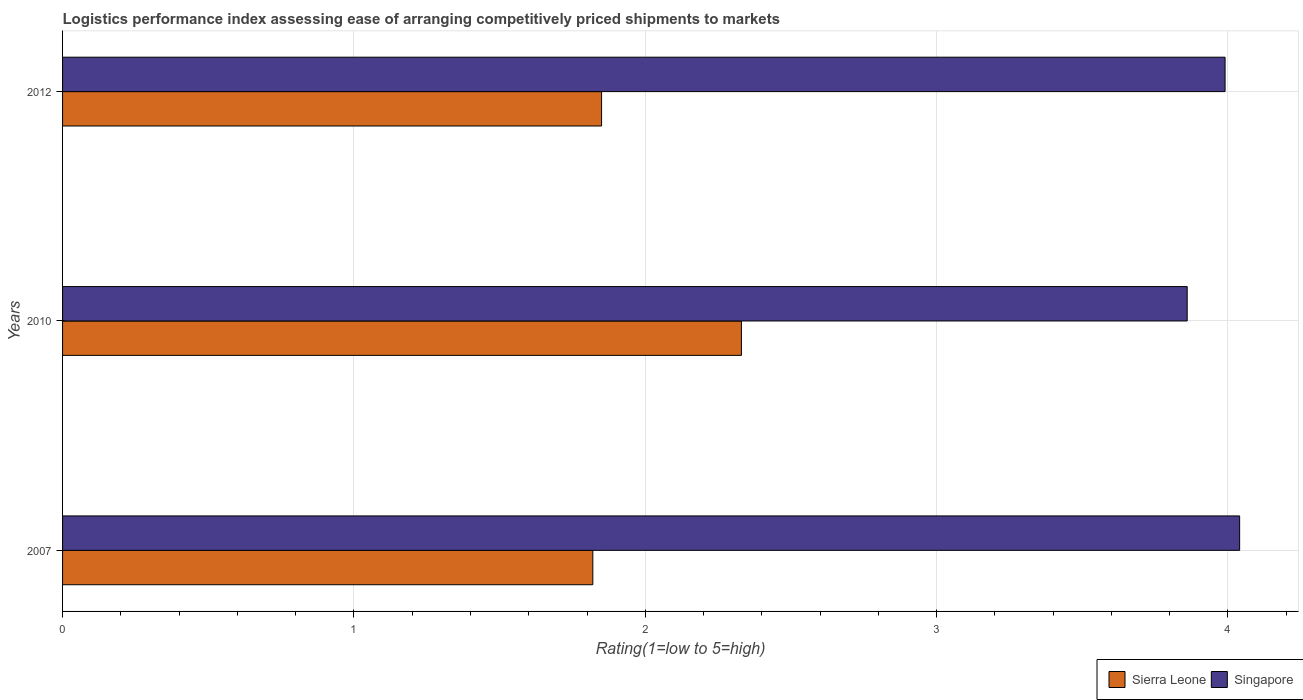How many different coloured bars are there?
Make the answer very short. 2. How many groups of bars are there?
Make the answer very short. 3. Are the number of bars per tick equal to the number of legend labels?
Offer a very short reply. Yes. In how many cases, is the number of bars for a given year not equal to the number of legend labels?
Keep it short and to the point. 0. What is the Logistic performance index in Sierra Leone in 2010?
Your answer should be compact. 2.33. Across all years, what is the maximum Logistic performance index in Singapore?
Keep it short and to the point. 4.04. Across all years, what is the minimum Logistic performance index in Sierra Leone?
Keep it short and to the point. 1.82. In which year was the Logistic performance index in Sierra Leone minimum?
Provide a succinct answer. 2007. What is the difference between the Logistic performance index in Singapore in 2007 and that in 2010?
Offer a very short reply. 0.18. What is the difference between the Logistic performance index in Singapore in 2010 and the Logistic performance index in Sierra Leone in 2007?
Provide a succinct answer. 2.04. What is the average Logistic performance index in Singapore per year?
Make the answer very short. 3.96. In the year 2010, what is the difference between the Logistic performance index in Singapore and Logistic performance index in Sierra Leone?
Your answer should be very brief. 1.53. In how many years, is the Logistic performance index in Sierra Leone greater than 3.4 ?
Offer a very short reply. 0. What is the ratio of the Logistic performance index in Sierra Leone in 2007 to that in 2012?
Provide a short and direct response. 0.98. Is the Logistic performance index in Sierra Leone in 2007 less than that in 2010?
Offer a terse response. Yes. Is the difference between the Logistic performance index in Singapore in 2010 and 2012 greater than the difference between the Logistic performance index in Sierra Leone in 2010 and 2012?
Your answer should be very brief. No. What is the difference between the highest and the second highest Logistic performance index in Sierra Leone?
Ensure brevity in your answer.  0.48. What is the difference between the highest and the lowest Logistic performance index in Singapore?
Ensure brevity in your answer.  0.18. In how many years, is the Logistic performance index in Singapore greater than the average Logistic performance index in Singapore taken over all years?
Offer a terse response. 2. Is the sum of the Logistic performance index in Singapore in 2007 and 2010 greater than the maximum Logistic performance index in Sierra Leone across all years?
Provide a short and direct response. Yes. What does the 2nd bar from the top in 2007 represents?
Ensure brevity in your answer.  Sierra Leone. What does the 1st bar from the bottom in 2010 represents?
Give a very brief answer. Sierra Leone. How many bars are there?
Keep it short and to the point. 6. How many years are there in the graph?
Your response must be concise. 3. What is the difference between two consecutive major ticks on the X-axis?
Your answer should be compact. 1. Are the values on the major ticks of X-axis written in scientific E-notation?
Provide a succinct answer. No. Does the graph contain any zero values?
Offer a terse response. No. Does the graph contain grids?
Keep it short and to the point. Yes. What is the title of the graph?
Your response must be concise. Logistics performance index assessing ease of arranging competitively priced shipments to markets. What is the label or title of the X-axis?
Your answer should be very brief. Rating(1=low to 5=high). What is the label or title of the Y-axis?
Your answer should be very brief. Years. What is the Rating(1=low to 5=high) in Sierra Leone in 2007?
Ensure brevity in your answer.  1.82. What is the Rating(1=low to 5=high) in Singapore in 2007?
Make the answer very short. 4.04. What is the Rating(1=low to 5=high) in Sierra Leone in 2010?
Provide a short and direct response. 2.33. What is the Rating(1=low to 5=high) of Singapore in 2010?
Your answer should be very brief. 3.86. What is the Rating(1=low to 5=high) in Sierra Leone in 2012?
Make the answer very short. 1.85. What is the Rating(1=low to 5=high) of Singapore in 2012?
Ensure brevity in your answer.  3.99. Across all years, what is the maximum Rating(1=low to 5=high) of Sierra Leone?
Give a very brief answer. 2.33. Across all years, what is the maximum Rating(1=low to 5=high) of Singapore?
Your answer should be compact. 4.04. Across all years, what is the minimum Rating(1=low to 5=high) of Sierra Leone?
Offer a very short reply. 1.82. Across all years, what is the minimum Rating(1=low to 5=high) of Singapore?
Give a very brief answer. 3.86. What is the total Rating(1=low to 5=high) of Singapore in the graph?
Your answer should be compact. 11.89. What is the difference between the Rating(1=low to 5=high) in Sierra Leone in 2007 and that in 2010?
Your answer should be very brief. -0.51. What is the difference between the Rating(1=low to 5=high) of Singapore in 2007 and that in 2010?
Your answer should be very brief. 0.18. What is the difference between the Rating(1=low to 5=high) of Sierra Leone in 2007 and that in 2012?
Provide a succinct answer. -0.03. What is the difference between the Rating(1=low to 5=high) in Singapore in 2007 and that in 2012?
Make the answer very short. 0.05. What is the difference between the Rating(1=low to 5=high) of Sierra Leone in 2010 and that in 2012?
Offer a terse response. 0.48. What is the difference between the Rating(1=low to 5=high) in Singapore in 2010 and that in 2012?
Offer a terse response. -0.13. What is the difference between the Rating(1=low to 5=high) in Sierra Leone in 2007 and the Rating(1=low to 5=high) in Singapore in 2010?
Your answer should be compact. -2.04. What is the difference between the Rating(1=low to 5=high) of Sierra Leone in 2007 and the Rating(1=low to 5=high) of Singapore in 2012?
Your answer should be very brief. -2.17. What is the difference between the Rating(1=low to 5=high) of Sierra Leone in 2010 and the Rating(1=low to 5=high) of Singapore in 2012?
Ensure brevity in your answer.  -1.66. What is the average Rating(1=low to 5=high) of Sierra Leone per year?
Give a very brief answer. 2. What is the average Rating(1=low to 5=high) of Singapore per year?
Provide a succinct answer. 3.96. In the year 2007, what is the difference between the Rating(1=low to 5=high) of Sierra Leone and Rating(1=low to 5=high) of Singapore?
Your answer should be compact. -2.22. In the year 2010, what is the difference between the Rating(1=low to 5=high) of Sierra Leone and Rating(1=low to 5=high) of Singapore?
Your answer should be very brief. -1.53. In the year 2012, what is the difference between the Rating(1=low to 5=high) of Sierra Leone and Rating(1=low to 5=high) of Singapore?
Your answer should be very brief. -2.14. What is the ratio of the Rating(1=low to 5=high) of Sierra Leone in 2007 to that in 2010?
Provide a succinct answer. 0.78. What is the ratio of the Rating(1=low to 5=high) in Singapore in 2007 to that in 2010?
Provide a short and direct response. 1.05. What is the ratio of the Rating(1=low to 5=high) in Sierra Leone in 2007 to that in 2012?
Offer a terse response. 0.98. What is the ratio of the Rating(1=low to 5=high) in Singapore in 2007 to that in 2012?
Make the answer very short. 1.01. What is the ratio of the Rating(1=low to 5=high) in Sierra Leone in 2010 to that in 2012?
Provide a succinct answer. 1.26. What is the ratio of the Rating(1=low to 5=high) of Singapore in 2010 to that in 2012?
Keep it short and to the point. 0.97. What is the difference between the highest and the second highest Rating(1=low to 5=high) in Sierra Leone?
Give a very brief answer. 0.48. What is the difference between the highest and the second highest Rating(1=low to 5=high) of Singapore?
Your answer should be very brief. 0.05. What is the difference between the highest and the lowest Rating(1=low to 5=high) of Sierra Leone?
Offer a very short reply. 0.51. What is the difference between the highest and the lowest Rating(1=low to 5=high) in Singapore?
Offer a terse response. 0.18. 